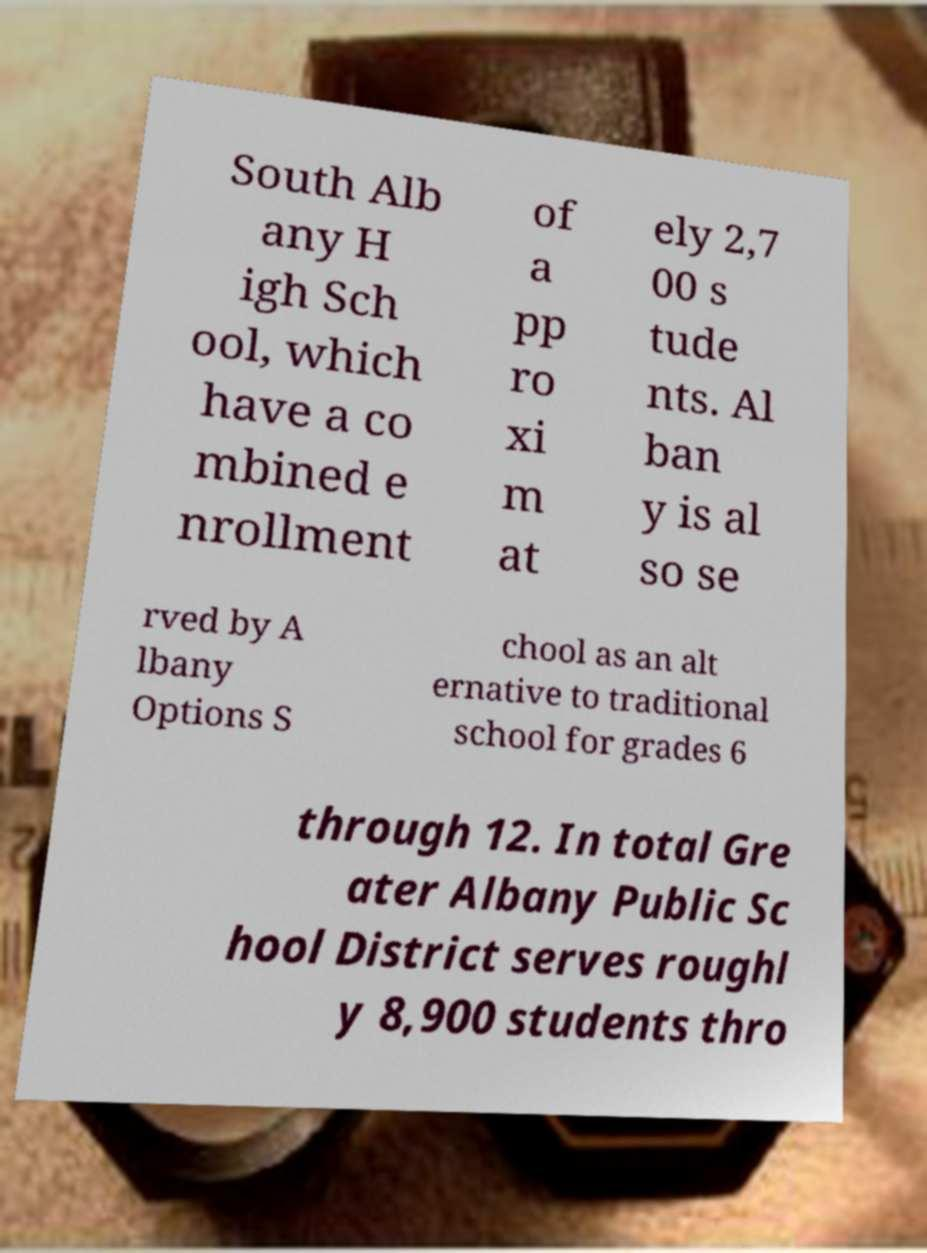I need the written content from this picture converted into text. Can you do that? South Alb any H igh Sch ool, which have a co mbined e nrollment of a pp ro xi m at ely 2,7 00 s tude nts. Al ban y is al so se rved by A lbany Options S chool as an alt ernative to traditional school for grades 6 through 12. In total Gre ater Albany Public Sc hool District serves roughl y 8,900 students thro 